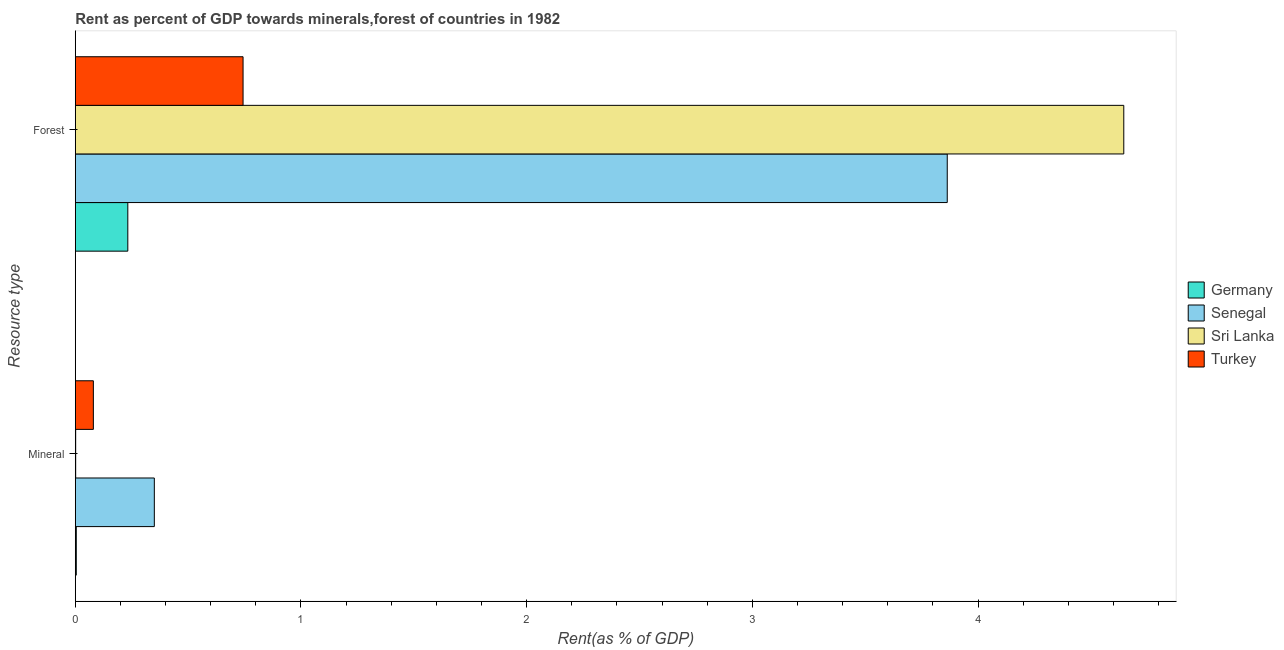How many different coloured bars are there?
Provide a short and direct response. 4. What is the label of the 1st group of bars from the top?
Offer a very short reply. Forest. What is the forest rent in Sri Lanka?
Offer a terse response. 4.65. Across all countries, what is the maximum forest rent?
Your answer should be very brief. 4.65. Across all countries, what is the minimum mineral rent?
Your answer should be very brief. 0. In which country was the mineral rent maximum?
Offer a very short reply. Senegal. What is the total forest rent in the graph?
Your answer should be very brief. 9.49. What is the difference between the mineral rent in Turkey and that in Germany?
Your response must be concise. 0.08. What is the difference between the mineral rent in Senegal and the forest rent in Germany?
Your answer should be very brief. 0.12. What is the average mineral rent per country?
Offer a very short reply. 0.11. What is the difference between the mineral rent and forest rent in Senegal?
Keep it short and to the point. -3.51. In how many countries, is the forest rent greater than 0.8 %?
Your response must be concise. 2. What is the ratio of the mineral rent in Sri Lanka to that in Senegal?
Offer a terse response. 0. In how many countries, is the forest rent greater than the average forest rent taken over all countries?
Your response must be concise. 2. What does the 1st bar from the bottom in Forest represents?
Give a very brief answer. Germany. How many bars are there?
Offer a terse response. 8. Does the graph contain grids?
Offer a very short reply. No. What is the title of the graph?
Your answer should be compact. Rent as percent of GDP towards minerals,forest of countries in 1982. Does "Brazil" appear as one of the legend labels in the graph?
Make the answer very short. No. What is the label or title of the X-axis?
Offer a very short reply. Rent(as % of GDP). What is the label or title of the Y-axis?
Offer a very short reply. Resource type. What is the Rent(as % of GDP) of Germany in Mineral?
Ensure brevity in your answer.  0. What is the Rent(as % of GDP) of Senegal in Mineral?
Your response must be concise. 0.35. What is the Rent(as % of GDP) in Sri Lanka in Mineral?
Your response must be concise. 0. What is the Rent(as % of GDP) in Turkey in Mineral?
Offer a terse response. 0.08. What is the Rent(as % of GDP) in Germany in Forest?
Your answer should be very brief. 0.23. What is the Rent(as % of GDP) of Senegal in Forest?
Your response must be concise. 3.86. What is the Rent(as % of GDP) in Sri Lanka in Forest?
Your answer should be very brief. 4.65. What is the Rent(as % of GDP) in Turkey in Forest?
Provide a succinct answer. 0.74. Across all Resource type, what is the maximum Rent(as % of GDP) in Germany?
Your answer should be compact. 0.23. Across all Resource type, what is the maximum Rent(as % of GDP) of Senegal?
Your answer should be very brief. 3.86. Across all Resource type, what is the maximum Rent(as % of GDP) of Sri Lanka?
Provide a succinct answer. 4.65. Across all Resource type, what is the maximum Rent(as % of GDP) of Turkey?
Offer a very short reply. 0.74. Across all Resource type, what is the minimum Rent(as % of GDP) of Germany?
Your answer should be very brief. 0. Across all Resource type, what is the minimum Rent(as % of GDP) of Senegal?
Make the answer very short. 0.35. Across all Resource type, what is the minimum Rent(as % of GDP) in Sri Lanka?
Keep it short and to the point. 0. Across all Resource type, what is the minimum Rent(as % of GDP) in Turkey?
Your response must be concise. 0.08. What is the total Rent(as % of GDP) of Germany in the graph?
Give a very brief answer. 0.24. What is the total Rent(as % of GDP) of Senegal in the graph?
Your answer should be compact. 4.21. What is the total Rent(as % of GDP) of Sri Lanka in the graph?
Your response must be concise. 4.65. What is the total Rent(as % of GDP) in Turkey in the graph?
Provide a short and direct response. 0.82. What is the difference between the Rent(as % of GDP) in Germany in Mineral and that in Forest?
Give a very brief answer. -0.23. What is the difference between the Rent(as % of GDP) in Senegal in Mineral and that in Forest?
Ensure brevity in your answer.  -3.51. What is the difference between the Rent(as % of GDP) in Sri Lanka in Mineral and that in Forest?
Give a very brief answer. -4.64. What is the difference between the Rent(as % of GDP) of Turkey in Mineral and that in Forest?
Offer a terse response. -0.66. What is the difference between the Rent(as % of GDP) of Germany in Mineral and the Rent(as % of GDP) of Senegal in Forest?
Give a very brief answer. -3.86. What is the difference between the Rent(as % of GDP) in Germany in Mineral and the Rent(as % of GDP) in Sri Lanka in Forest?
Your answer should be very brief. -4.64. What is the difference between the Rent(as % of GDP) of Germany in Mineral and the Rent(as % of GDP) of Turkey in Forest?
Provide a short and direct response. -0.74. What is the difference between the Rent(as % of GDP) in Senegal in Mineral and the Rent(as % of GDP) in Sri Lanka in Forest?
Keep it short and to the point. -4.3. What is the difference between the Rent(as % of GDP) in Senegal in Mineral and the Rent(as % of GDP) in Turkey in Forest?
Provide a short and direct response. -0.39. What is the difference between the Rent(as % of GDP) of Sri Lanka in Mineral and the Rent(as % of GDP) of Turkey in Forest?
Offer a very short reply. -0.74. What is the average Rent(as % of GDP) in Germany per Resource type?
Give a very brief answer. 0.12. What is the average Rent(as % of GDP) of Senegal per Resource type?
Provide a succinct answer. 2.11. What is the average Rent(as % of GDP) in Sri Lanka per Resource type?
Ensure brevity in your answer.  2.32. What is the average Rent(as % of GDP) in Turkey per Resource type?
Your answer should be very brief. 0.41. What is the difference between the Rent(as % of GDP) of Germany and Rent(as % of GDP) of Senegal in Mineral?
Your answer should be very brief. -0.35. What is the difference between the Rent(as % of GDP) in Germany and Rent(as % of GDP) in Sri Lanka in Mineral?
Provide a short and direct response. 0. What is the difference between the Rent(as % of GDP) of Germany and Rent(as % of GDP) of Turkey in Mineral?
Your answer should be compact. -0.08. What is the difference between the Rent(as % of GDP) in Senegal and Rent(as % of GDP) in Sri Lanka in Mineral?
Ensure brevity in your answer.  0.35. What is the difference between the Rent(as % of GDP) in Senegal and Rent(as % of GDP) in Turkey in Mineral?
Keep it short and to the point. 0.27. What is the difference between the Rent(as % of GDP) of Sri Lanka and Rent(as % of GDP) of Turkey in Mineral?
Offer a terse response. -0.08. What is the difference between the Rent(as % of GDP) in Germany and Rent(as % of GDP) in Senegal in Forest?
Offer a terse response. -3.63. What is the difference between the Rent(as % of GDP) of Germany and Rent(as % of GDP) of Sri Lanka in Forest?
Your response must be concise. -4.41. What is the difference between the Rent(as % of GDP) in Germany and Rent(as % of GDP) in Turkey in Forest?
Provide a short and direct response. -0.51. What is the difference between the Rent(as % of GDP) in Senegal and Rent(as % of GDP) in Sri Lanka in Forest?
Make the answer very short. -0.78. What is the difference between the Rent(as % of GDP) of Senegal and Rent(as % of GDP) of Turkey in Forest?
Provide a succinct answer. 3.12. What is the difference between the Rent(as % of GDP) of Sri Lanka and Rent(as % of GDP) of Turkey in Forest?
Your answer should be very brief. 3.9. What is the ratio of the Rent(as % of GDP) of Germany in Mineral to that in Forest?
Offer a terse response. 0.02. What is the ratio of the Rent(as % of GDP) in Senegal in Mineral to that in Forest?
Offer a very short reply. 0.09. What is the ratio of the Rent(as % of GDP) of Turkey in Mineral to that in Forest?
Your answer should be compact. 0.11. What is the difference between the highest and the second highest Rent(as % of GDP) in Germany?
Ensure brevity in your answer.  0.23. What is the difference between the highest and the second highest Rent(as % of GDP) of Senegal?
Keep it short and to the point. 3.51. What is the difference between the highest and the second highest Rent(as % of GDP) of Sri Lanka?
Provide a short and direct response. 4.64. What is the difference between the highest and the second highest Rent(as % of GDP) of Turkey?
Provide a short and direct response. 0.66. What is the difference between the highest and the lowest Rent(as % of GDP) in Germany?
Your answer should be compact. 0.23. What is the difference between the highest and the lowest Rent(as % of GDP) in Senegal?
Provide a succinct answer. 3.51. What is the difference between the highest and the lowest Rent(as % of GDP) of Sri Lanka?
Your answer should be compact. 4.64. What is the difference between the highest and the lowest Rent(as % of GDP) of Turkey?
Provide a succinct answer. 0.66. 